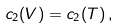Convert formula to latex. <formula><loc_0><loc_0><loc_500><loc_500>c _ { 2 } ( V ) = c _ { 2 } ( T ) \, ,</formula> 